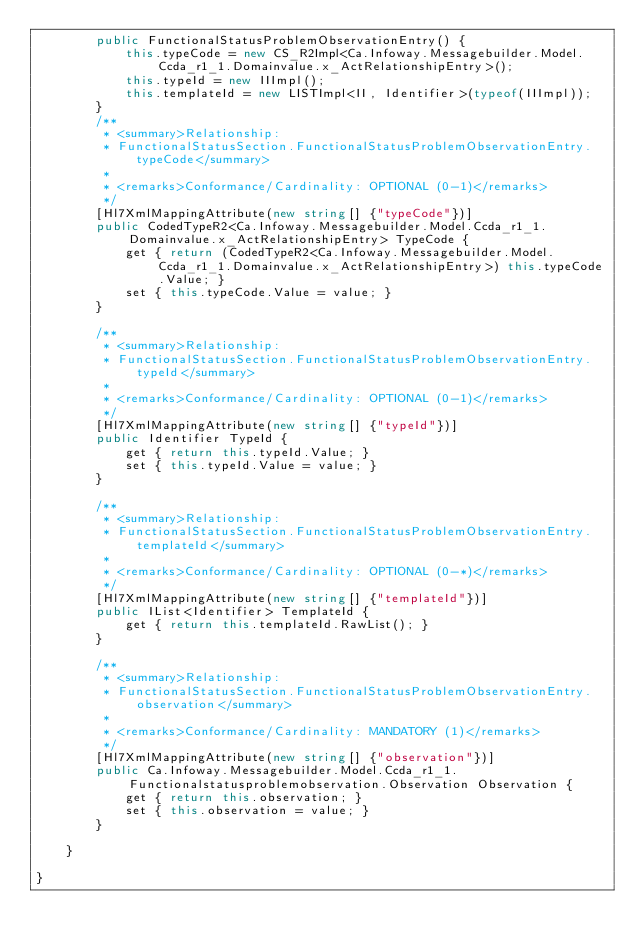<code> <loc_0><loc_0><loc_500><loc_500><_C#_>        public FunctionalStatusProblemObservationEntry() {
            this.typeCode = new CS_R2Impl<Ca.Infoway.Messagebuilder.Model.Ccda_r1_1.Domainvalue.x_ActRelationshipEntry>();
            this.typeId = new IIImpl();
            this.templateId = new LISTImpl<II, Identifier>(typeof(IIImpl));
        }
        /**
         * <summary>Relationship: 
         * FunctionalStatusSection.FunctionalStatusProblemObservationEntry.typeCode</summary>
         * 
         * <remarks>Conformance/Cardinality: OPTIONAL (0-1)</remarks>
         */
        [Hl7XmlMappingAttribute(new string[] {"typeCode"})]
        public CodedTypeR2<Ca.Infoway.Messagebuilder.Model.Ccda_r1_1.Domainvalue.x_ActRelationshipEntry> TypeCode {
            get { return (CodedTypeR2<Ca.Infoway.Messagebuilder.Model.Ccda_r1_1.Domainvalue.x_ActRelationshipEntry>) this.typeCode.Value; }
            set { this.typeCode.Value = value; }
        }

        /**
         * <summary>Relationship: 
         * FunctionalStatusSection.FunctionalStatusProblemObservationEntry.typeId</summary>
         * 
         * <remarks>Conformance/Cardinality: OPTIONAL (0-1)</remarks>
         */
        [Hl7XmlMappingAttribute(new string[] {"typeId"})]
        public Identifier TypeId {
            get { return this.typeId.Value; }
            set { this.typeId.Value = value; }
        }

        /**
         * <summary>Relationship: 
         * FunctionalStatusSection.FunctionalStatusProblemObservationEntry.templateId</summary>
         * 
         * <remarks>Conformance/Cardinality: OPTIONAL (0-*)</remarks>
         */
        [Hl7XmlMappingAttribute(new string[] {"templateId"})]
        public IList<Identifier> TemplateId {
            get { return this.templateId.RawList(); }
        }

        /**
         * <summary>Relationship: 
         * FunctionalStatusSection.FunctionalStatusProblemObservationEntry.observation</summary>
         * 
         * <remarks>Conformance/Cardinality: MANDATORY (1)</remarks>
         */
        [Hl7XmlMappingAttribute(new string[] {"observation"})]
        public Ca.Infoway.Messagebuilder.Model.Ccda_r1_1.Functionalstatusproblemobservation.Observation Observation {
            get { return this.observation; }
            set { this.observation = value; }
        }

    }

}</code> 